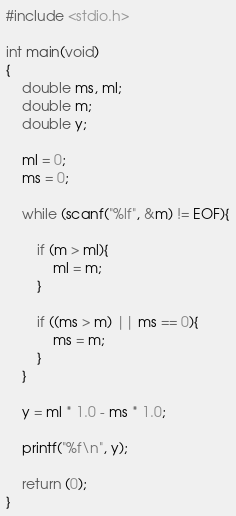<code> <loc_0><loc_0><loc_500><loc_500><_C_>#include <stdio.h>

int main(void)
{
	double ms, ml;
	double m;
	double y;
	
	ml = 0;
	ms = 0;
	
	while (scanf("%lf", &m) != EOF){
		
		if (m > ml){
			ml = m;
		}
		
		if ((ms > m) || ms == 0){
			ms = m;
		}
	}
	
	y = ml * 1.0 - ms * 1.0;
	
	printf("%f\n", y);
	
	return (0);
}</code> 